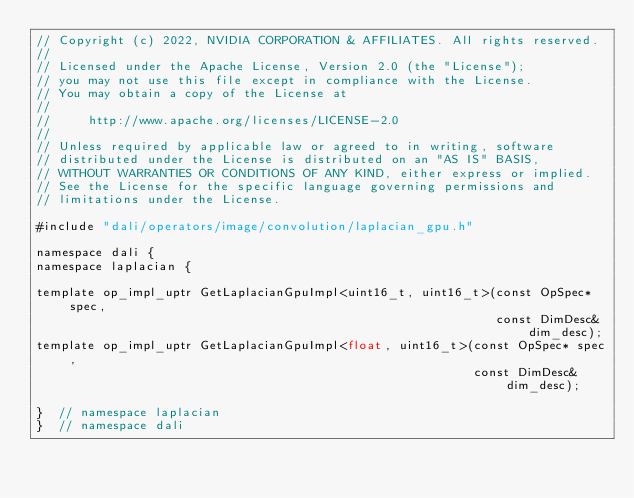<code> <loc_0><loc_0><loc_500><loc_500><_Cuda_>// Copyright (c) 2022, NVIDIA CORPORATION & AFFILIATES. All rights reserved.
//
// Licensed under the Apache License, Version 2.0 (the "License");
// you may not use this file except in compliance with the License.
// You may obtain a copy of the License at
//
//     http://www.apache.org/licenses/LICENSE-2.0
//
// Unless required by applicable law or agreed to in writing, software
// distributed under the License is distributed on an "AS IS" BASIS,
// WITHOUT WARRANTIES OR CONDITIONS OF ANY KIND, either express or implied.
// See the License for the specific language governing permissions and
// limitations under the License.

#include "dali/operators/image/convolution/laplacian_gpu.h"

namespace dali {
namespace laplacian {

template op_impl_uptr GetLaplacianGpuImpl<uint16_t, uint16_t>(const OpSpec* spec,
                                                              const DimDesc& dim_desc);
template op_impl_uptr GetLaplacianGpuImpl<float, uint16_t>(const OpSpec* spec,
                                                           const DimDesc& dim_desc);

}  // namespace laplacian
}  // namespace dali
</code> 